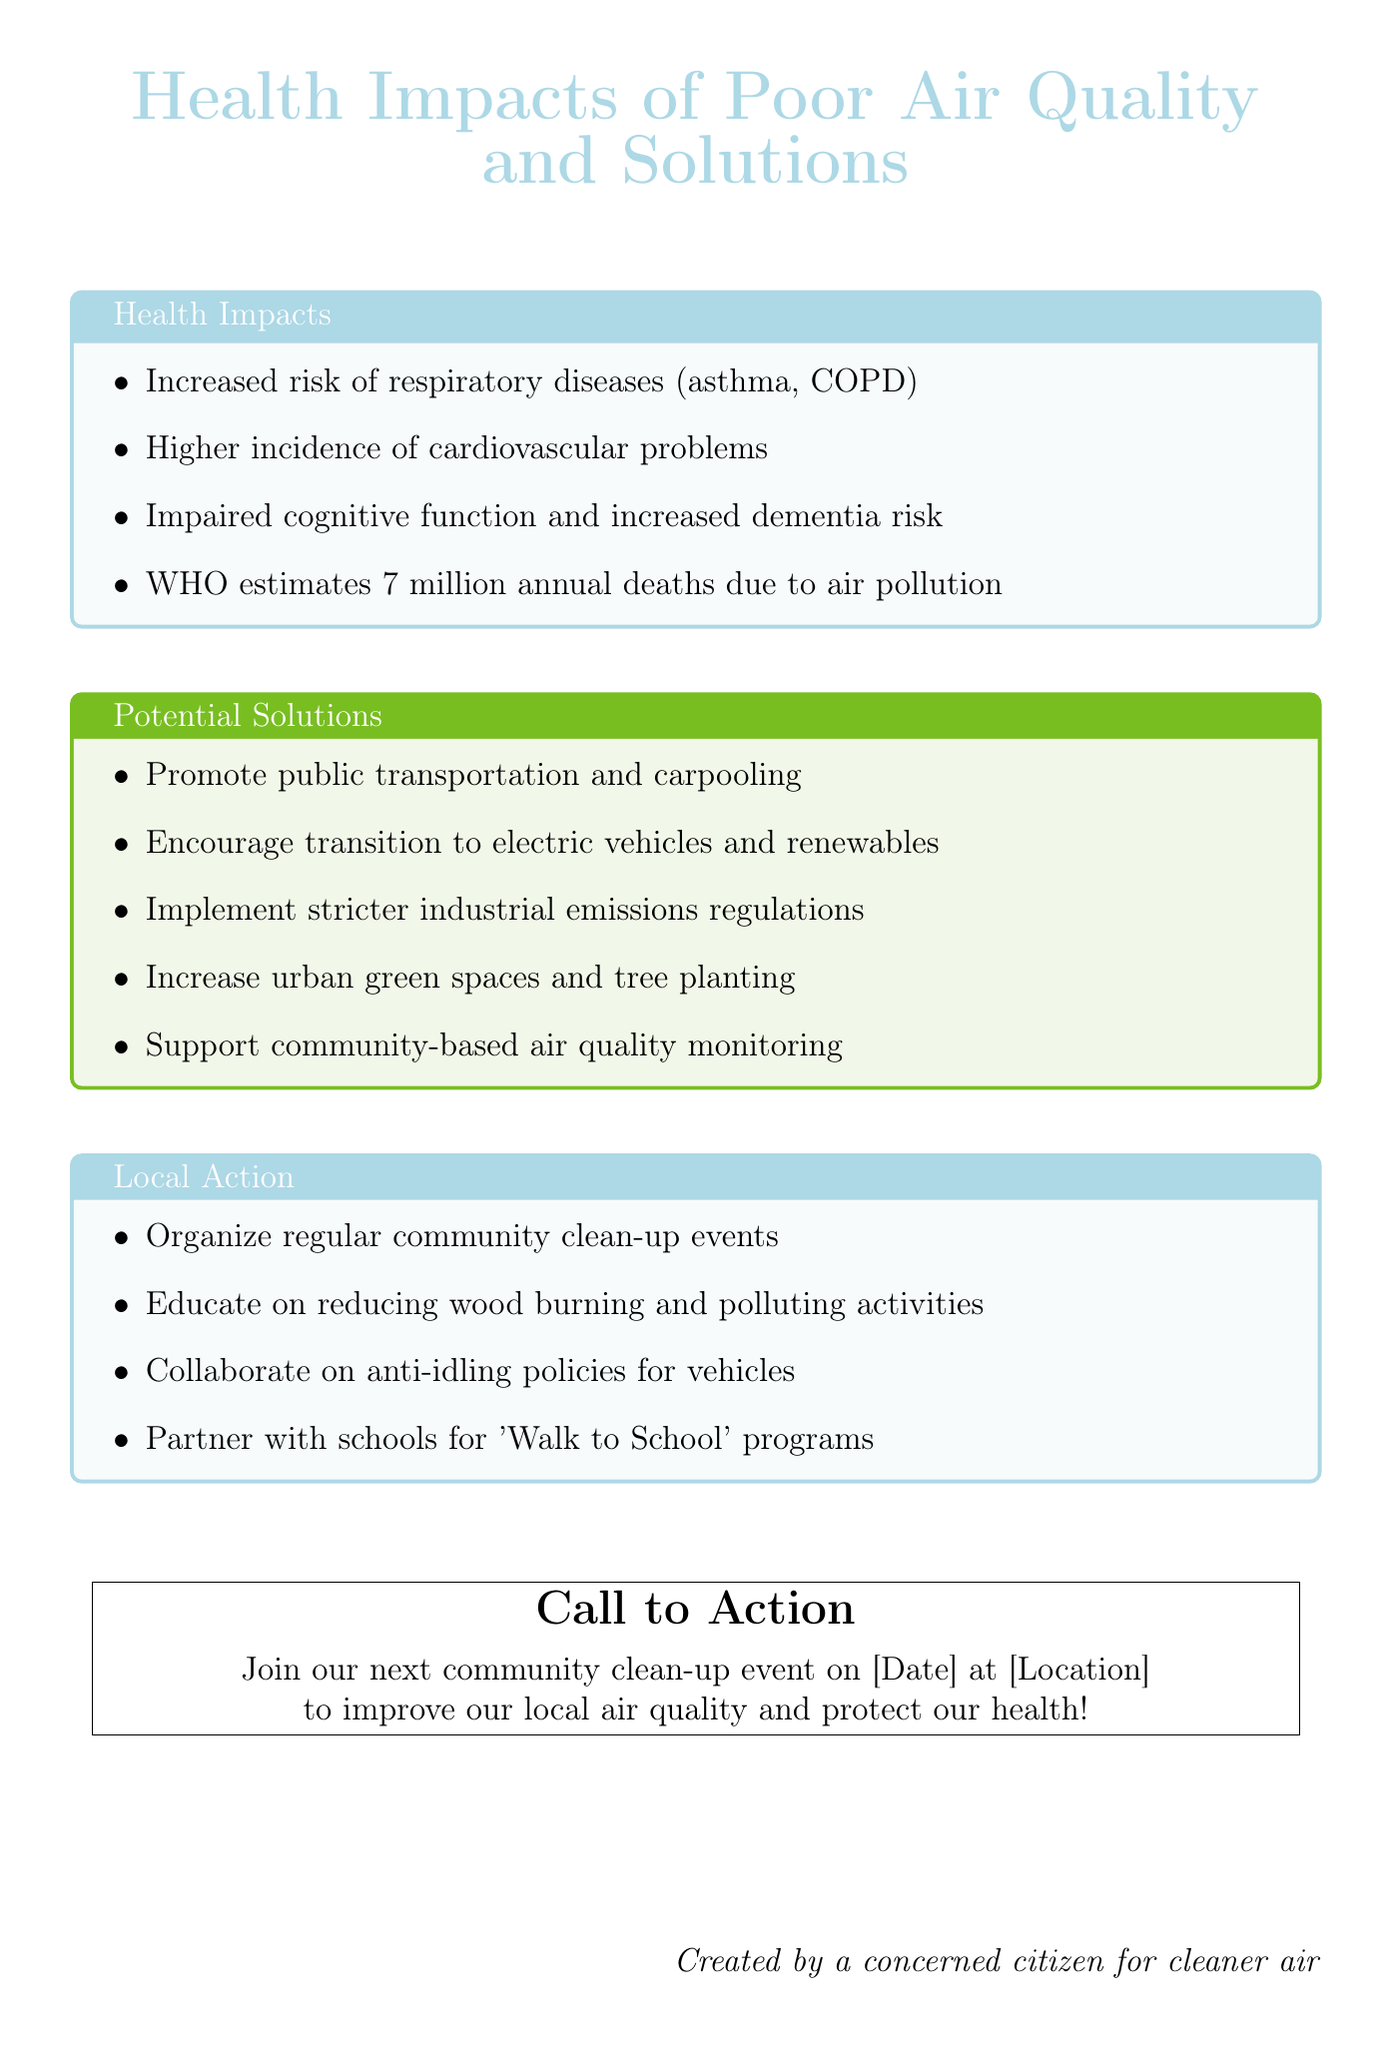What is the title of the document? The title of the document is explicitly stated at the beginning as "Health Impacts of Poor Air Quality and Solutions".
Answer: Health Impacts of Poor Air Quality and Solutions How many deaths are estimated annually due to air pollution according to WHO? The document mentions that the WHO estimates 7 million deaths annually due to air pollution.
Answer: 7 million What disease is associated with an increased risk due to poor air quality mentioned in the health impacts? One of the specific respiratory diseases associated with poor air quality is asthma, as noted in the health impacts section.
Answer: asthma What is one potential solution to improve air quality mentioned? The document lists various solutions, and one instance is encouraging the transition to electric vehicles and renewable energy sources.
Answer: transition to electric vehicles and renewable energy sources What local action involves schools according to the document? The document specifies a local action that includes partnering with schools to create 'Walk to School' programs.
Answer: 'Walk to School' programs What should residents be educated about to help reduce pollution? The document states that residents should be educated on the importance of reducing wood burning and other polluting activities.
Answer: reducing wood burning and other polluting activities When is the next community clean-up event mentioned in the call to action? The document provides a call to action but leaves the specific date and location as placeholders.
Answer: [Date] What organization estimates the higher incidence of cardiovascular problems? The document states that the World Health Organization is responsible for the estimates related to cardiovascular problems due to poor air quality.
Answer: World Health Organization 